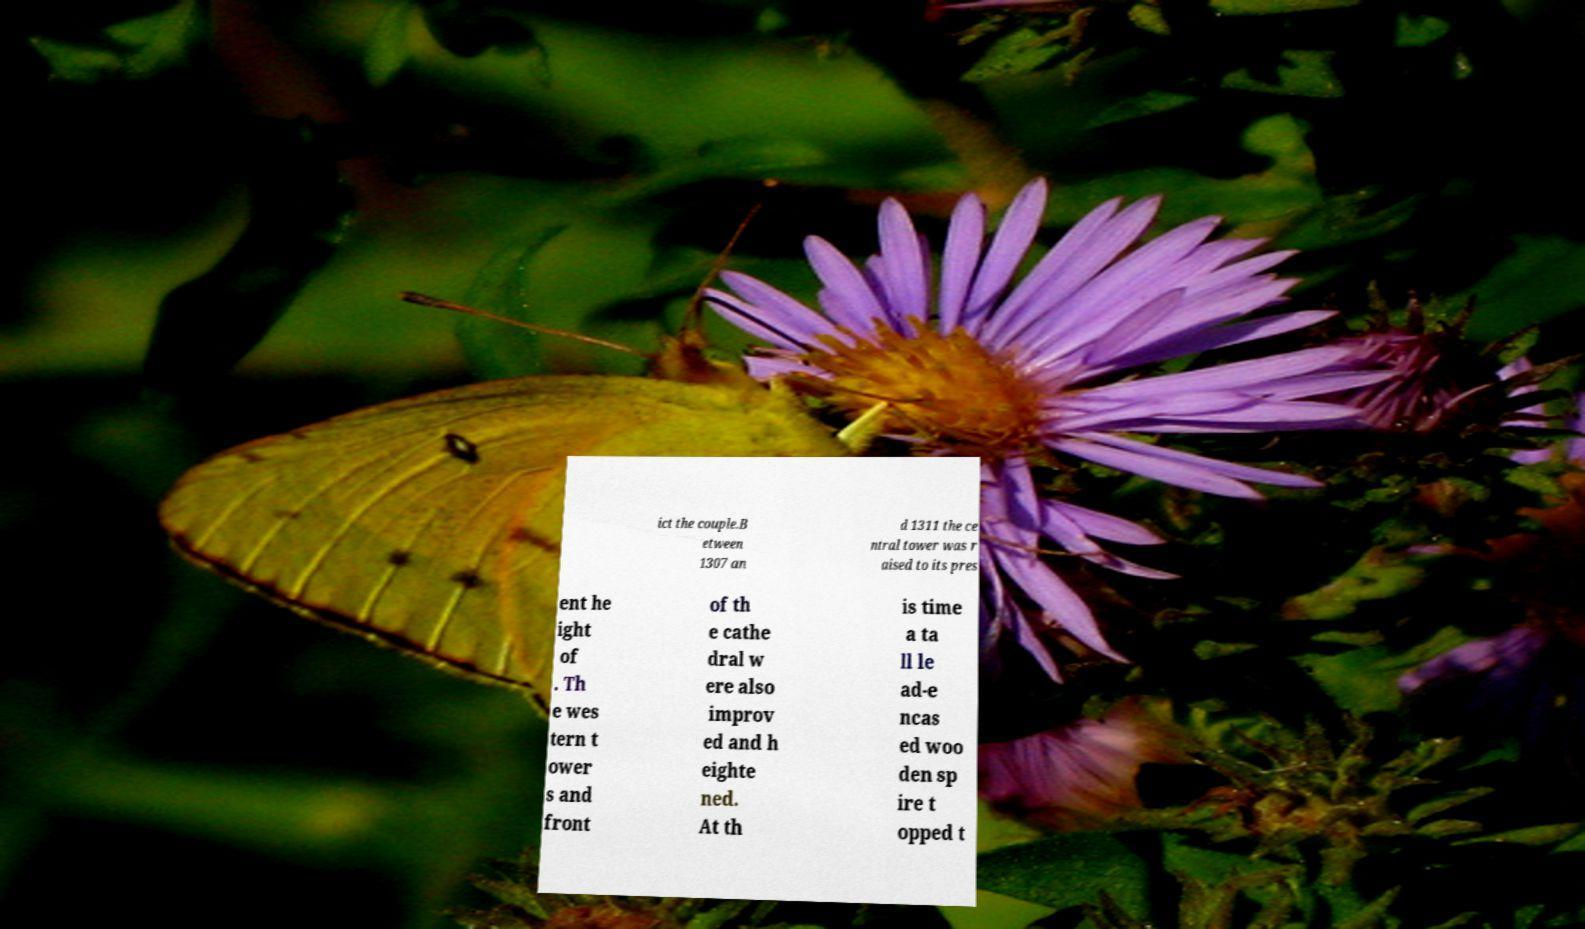There's text embedded in this image that I need extracted. Can you transcribe it verbatim? ict the couple.B etween 1307 an d 1311 the ce ntral tower was r aised to its pres ent he ight of . Th e wes tern t ower s and front of th e cathe dral w ere also improv ed and h eighte ned. At th is time a ta ll le ad-e ncas ed woo den sp ire t opped t 